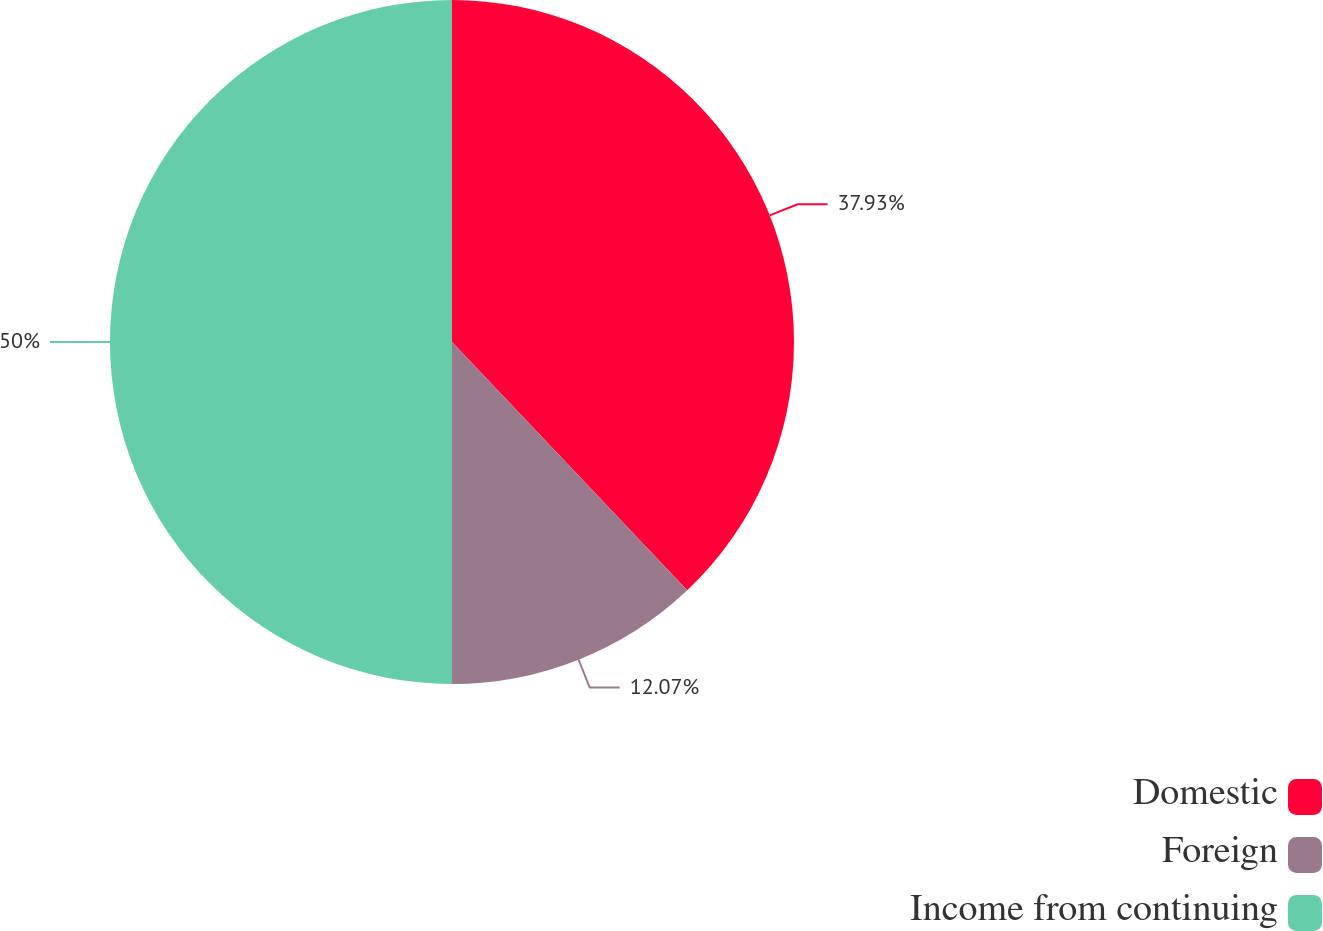Convert chart to OTSL. <chart><loc_0><loc_0><loc_500><loc_500><pie_chart><fcel>Domestic<fcel>Foreign<fcel>Income from continuing<nl><fcel>37.93%<fcel>12.07%<fcel>50.0%<nl></chart> 